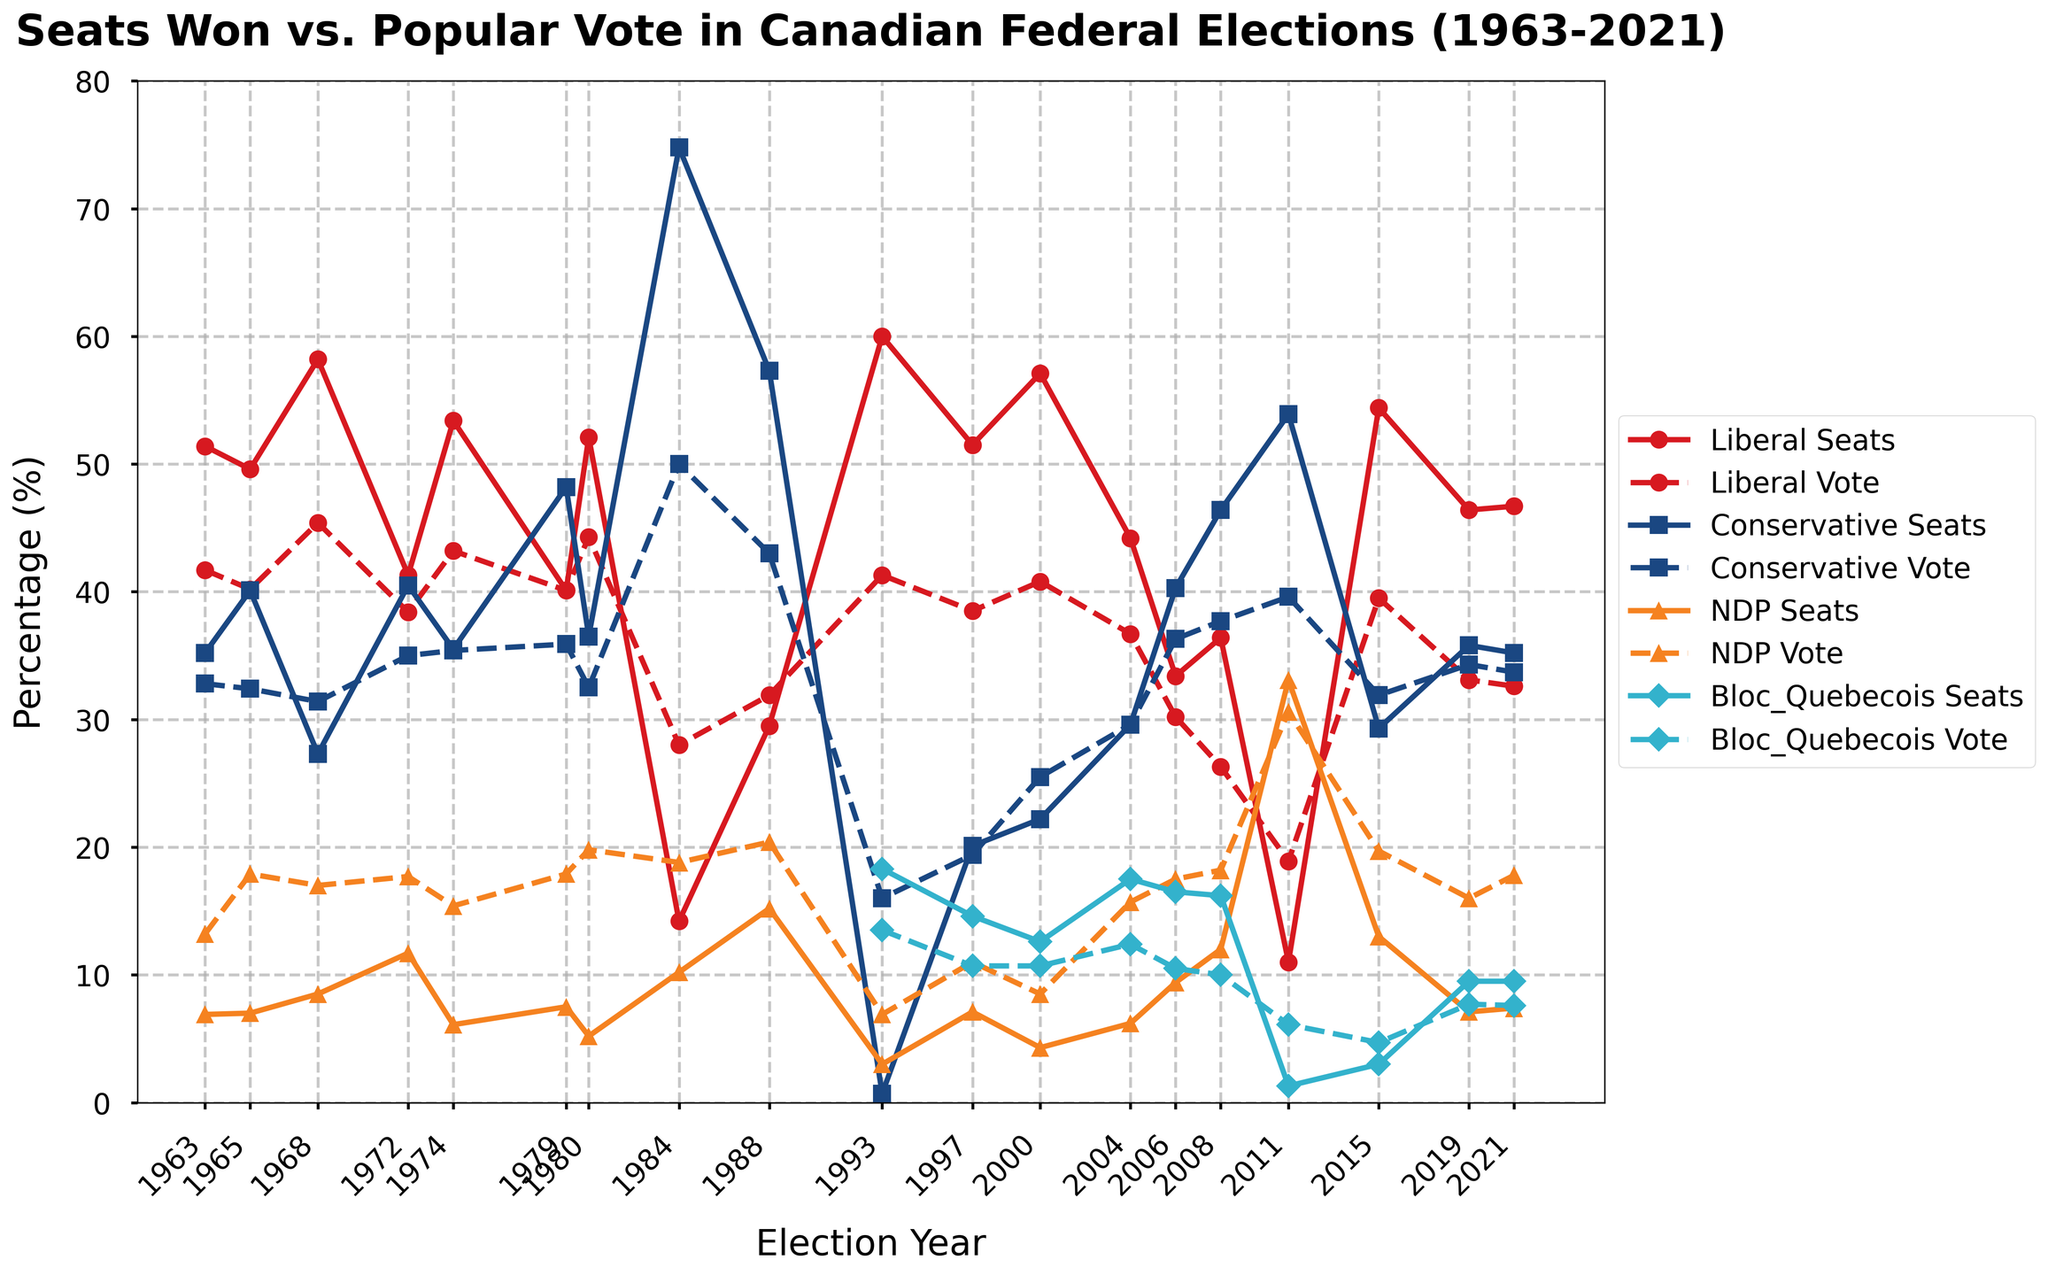Which party had the largest discrepancy between seats won and the popular vote in 1984? In 1984, the Conservative Party had 74.8% of the seats but only 50.0% of the popular vote, resulting in a discrepancy of 74.8 - 50.0 = 24.8. The Liberal Party's discrepancy was 28.0 - 14.2 = 13.8. The NDP's discrepancy was 18.8 - 10.2 = 8.6. Thus, the Conservative Party had the largest discrepancy.
Answer: Conservative Party In which election year did the Liberal Party win the highest percentage of seats relative to the popular vote? To find the election year, we look for the year when the difference between Liberal_Seats and Liberal_Vote is the highest. In 1993, the Liberal Party had 60.0% of the seats compared to 41.3% of the vote, resulting in a difference of 60.0 - 41.3 = 18.7, which is the highest.
Answer: 1993 How many times did the NDP win more than 10% of the seats? Checking the NDP_Seats percentage column, we see that the NDP won more than 10% of the seats in 1972 (11.7%), 1988 (15.2%), 2004 (6.2%), 2006 (9.4%), 2008 (12.0%), and 2011 (33.1%). Thus, they won more than 10% of the seats 4 times.
Answer: 4 times In which year did the Bloc Quebecois win the highest percentage of the popular vote? The highest Bloc_Quebecois_Vote value is 13.5% in 1993. Thus, the Bloc Quebecois won the highest percentage of the popular vote in 1993.
Answer: 1993 Which party had a higher percentage of the popular vote than the percentage of seats won in 2019? In 2019, comparing the popular vote and seats won for each party:  
Liberal: 33.1% vote, 46.4% seats - Votes < Seats  
Conservative: 34.3% vote, 35.8% seats - Votes < Seats  
NDP: 16.0% vote, 7.1% seats - Votes > Seats  
Bloc Quebecois: 7.7% vote, 9.5% seats - Votes < Seats   
The NDP had a higher percentage of the popular vote than the percentage of seats won.
Answer: NDP Which party's line for seats won shows the most rapid increase between two consecutive elections? Examining the plot, look for the steepest upward slope between two consecutive points for each party's seats line. The NDP's seats increased dramatically from 12.0% in 2008 to 33.1% in 2011, which appears to be the most rapid increase.
Answer: NDP What is the general trend for the Conservative Party between 1979 and 1984 in terms of seats won and popular vote? Between 1979 and 1984, the Conservative Party's seats won increased from 48.2% to 74.8%. Their popular vote also increased from 35.9% to 50.0%. The general trend is a significant increase in both seats won and popular vote.
Answer: Significant increase How do the visual patterns of seats won and popular vote look for the Liberal and Conservative parties after 2000? After 2000, the Liberal Party's seats won and popular vote lines show fluctuations but generally remain close to each other. The Conservative Party's popular vote line is generally close to their seats won line, with a notable exception in 2011 where seats won (53.9%) is significantly higher than popular vote (39.6%).
Answer: Fluctuates, generally close 